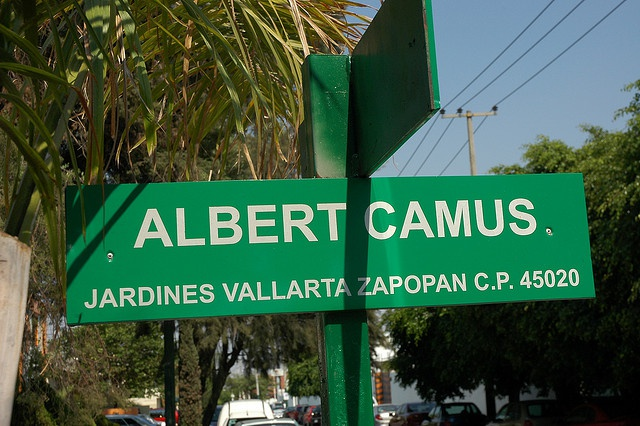Describe the objects in this image and their specific colors. I can see car in black, gray, and purple tones, car in black, teal, purple, and darkblue tones, car in black, ivory, darkgray, and gray tones, car in black, gray, darkblue, and purple tones, and car in black, gray, and purple tones in this image. 